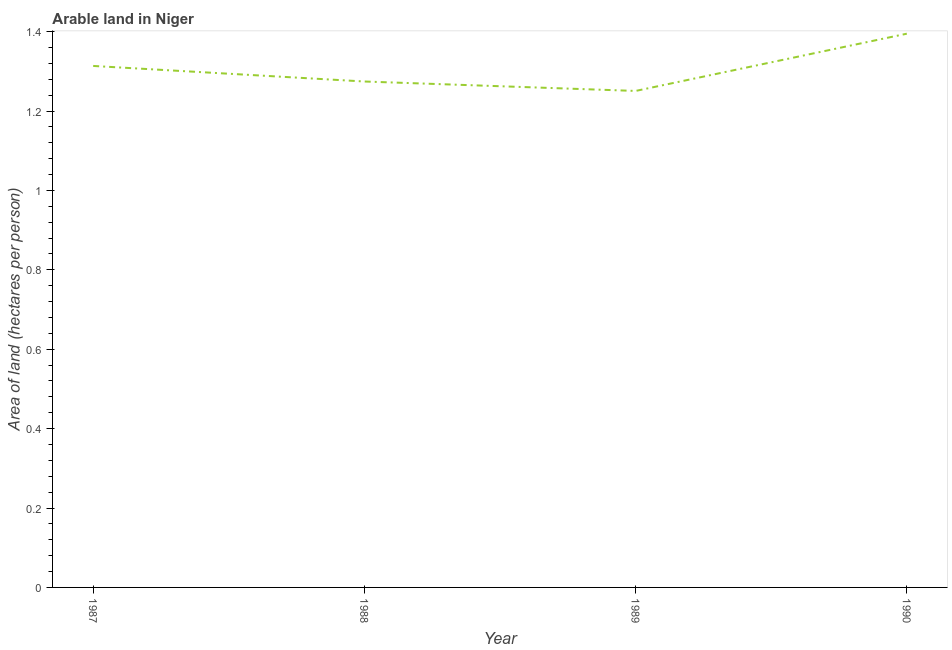What is the area of arable land in 1987?
Your response must be concise. 1.31. Across all years, what is the maximum area of arable land?
Give a very brief answer. 1.39. Across all years, what is the minimum area of arable land?
Your answer should be compact. 1.25. In which year was the area of arable land minimum?
Provide a succinct answer. 1989. What is the sum of the area of arable land?
Make the answer very short. 5.23. What is the difference between the area of arable land in 1989 and 1990?
Offer a terse response. -0.14. What is the average area of arable land per year?
Provide a short and direct response. 1.31. What is the median area of arable land?
Your answer should be compact. 1.29. What is the ratio of the area of arable land in 1988 to that in 1990?
Your response must be concise. 0.91. Is the area of arable land in 1989 less than that in 1990?
Provide a succinct answer. Yes. Is the difference between the area of arable land in 1987 and 1989 greater than the difference between any two years?
Your answer should be very brief. No. What is the difference between the highest and the second highest area of arable land?
Your answer should be compact. 0.08. Is the sum of the area of arable land in 1988 and 1990 greater than the maximum area of arable land across all years?
Provide a short and direct response. Yes. What is the difference between the highest and the lowest area of arable land?
Your answer should be compact. 0.14. In how many years, is the area of arable land greater than the average area of arable land taken over all years?
Make the answer very short. 2. Does the area of arable land monotonically increase over the years?
Make the answer very short. No. How many years are there in the graph?
Offer a terse response. 4. Does the graph contain grids?
Give a very brief answer. No. What is the title of the graph?
Provide a short and direct response. Arable land in Niger. What is the label or title of the Y-axis?
Make the answer very short. Area of land (hectares per person). What is the Area of land (hectares per person) in 1987?
Your answer should be compact. 1.31. What is the Area of land (hectares per person) in 1988?
Make the answer very short. 1.27. What is the Area of land (hectares per person) in 1989?
Your response must be concise. 1.25. What is the Area of land (hectares per person) in 1990?
Provide a short and direct response. 1.39. What is the difference between the Area of land (hectares per person) in 1987 and 1988?
Your answer should be very brief. 0.04. What is the difference between the Area of land (hectares per person) in 1987 and 1989?
Your answer should be very brief. 0.06. What is the difference between the Area of land (hectares per person) in 1987 and 1990?
Provide a short and direct response. -0.08. What is the difference between the Area of land (hectares per person) in 1988 and 1989?
Provide a succinct answer. 0.02. What is the difference between the Area of land (hectares per person) in 1988 and 1990?
Make the answer very short. -0.12. What is the difference between the Area of land (hectares per person) in 1989 and 1990?
Your answer should be compact. -0.14. What is the ratio of the Area of land (hectares per person) in 1987 to that in 1988?
Your answer should be compact. 1.03. What is the ratio of the Area of land (hectares per person) in 1987 to that in 1990?
Offer a terse response. 0.94. What is the ratio of the Area of land (hectares per person) in 1988 to that in 1990?
Provide a short and direct response. 0.91. What is the ratio of the Area of land (hectares per person) in 1989 to that in 1990?
Your response must be concise. 0.9. 